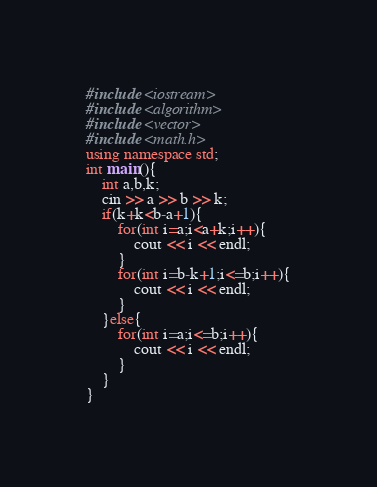<code> <loc_0><loc_0><loc_500><loc_500><_C++_>#include <iostream>
#include <algorithm>
#include <vector>
#include <math.h>
using namespace std;
int main(){
    int a,b,k;
    cin >> a >> b >> k;
    if(k+k<b-a+1){
        for(int i=a;i<a+k;i++){
            cout << i << endl;
        }
        for(int i=b-k+1;i<=b;i++){
            cout << i << endl;
        }
    }else{
        for(int i=a;i<=b;i++){
            cout << i << endl;
        }
    }
}</code> 